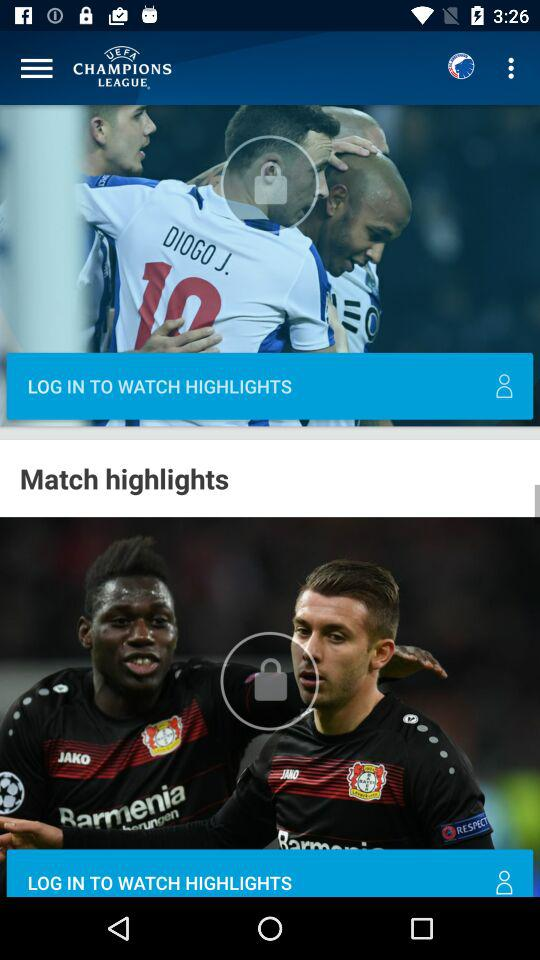How many items are locked?
Answer the question using a single word or phrase. 2 